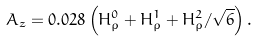<formula> <loc_0><loc_0><loc_500><loc_500>A _ { z } = 0 . 0 2 8 \left ( H _ { \rho } ^ { 0 } + H _ { \rho } ^ { 1 } + H _ { \rho } ^ { 2 } / \sqrt { 6 } \right ) .</formula> 